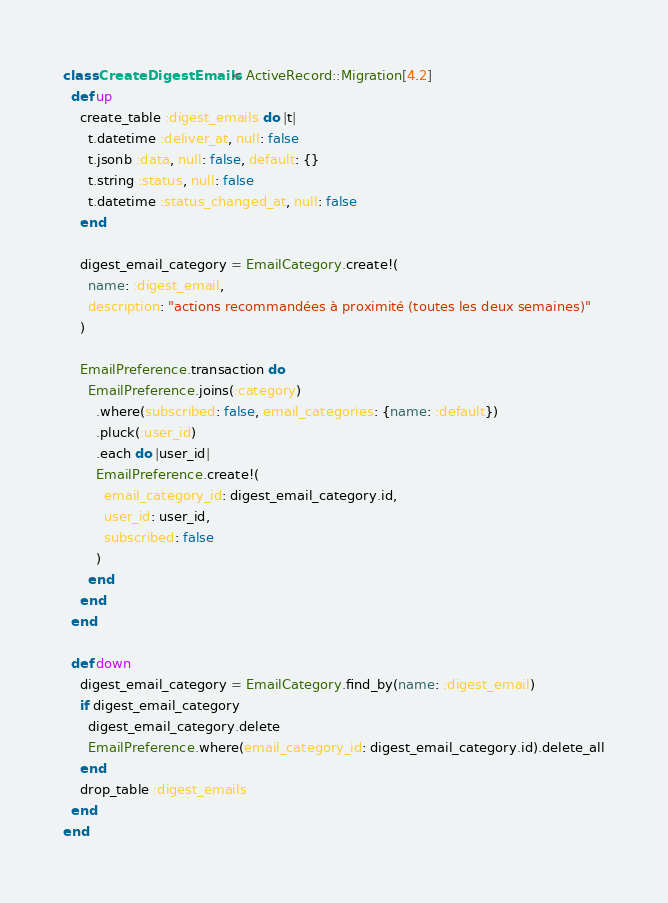Convert code to text. <code><loc_0><loc_0><loc_500><loc_500><_Ruby_>class CreateDigestEmails < ActiveRecord::Migration[4.2]
  def up
    create_table :digest_emails do |t|
      t.datetime :deliver_at, null: false
      t.jsonb :data, null: false, default: {}
      t.string :status, null: false
      t.datetime :status_changed_at, null: false
    end

    digest_email_category = EmailCategory.create!(
      name: :digest_email,
      description: "actions recommandées à proximité (toutes les deux semaines)"
    )

    EmailPreference.transaction do
      EmailPreference.joins(:category)
        .where(subscribed: false, email_categories: {name: :default})
        .pluck(:user_id)
        .each do |user_id|
        EmailPreference.create!(
          email_category_id: digest_email_category.id,
          user_id: user_id,
          subscribed: false
        )
      end
    end
  end

  def down
    digest_email_category = EmailCategory.find_by(name: :digest_email)
    if digest_email_category
      digest_email_category.delete
      EmailPreference.where(email_category_id: digest_email_category.id).delete_all
    end
    drop_table :digest_emails
  end
end
</code> 